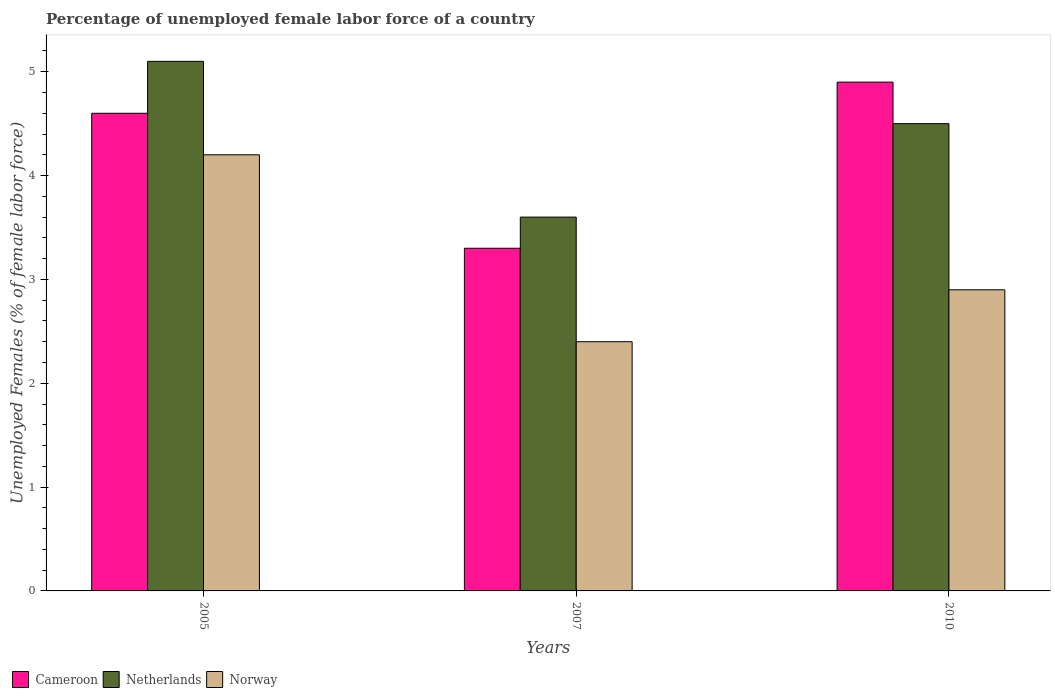How many groups of bars are there?
Provide a short and direct response. 3. Are the number of bars per tick equal to the number of legend labels?
Offer a very short reply. Yes. How many bars are there on the 1st tick from the left?
Provide a short and direct response. 3. How many bars are there on the 1st tick from the right?
Your answer should be compact. 3. What is the label of the 2nd group of bars from the left?
Your answer should be compact. 2007. What is the percentage of unemployed female labor force in Norway in 2010?
Keep it short and to the point. 2.9. Across all years, what is the maximum percentage of unemployed female labor force in Netherlands?
Ensure brevity in your answer.  5.1. Across all years, what is the minimum percentage of unemployed female labor force in Cameroon?
Provide a succinct answer. 3.3. In which year was the percentage of unemployed female labor force in Netherlands minimum?
Your response must be concise. 2007. What is the total percentage of unemployed female labor force in Cameroon in the graph?
Provide a succinct answer. 12.8. What is the difference between the percentage of unemployed female labor force in Norway in 2007 and that in 2010?
Give a very brief answer. -0.5. What is the difference between the percentage of unemployed female labor force in Cameroon in 2010 and the percentage of unemployed female labor force in Netherlands in 2005?
Your response must be concise. -0.2. What is the average percentage of unemployed female labor force in Norway per year?
Offer a terse response. 3.17. In the year 2007, what is the difference between the percentage of unemployed female labor force in Norway and percentage of unemployed female labor force in Netherlands?
Your answer should be very brief. -1.2. What is the ratio of the percentage of unemployed female labor force in Norway in 2005 to that in 2007?
Offer a terse response. 1.75. Is the percentage of unemployed female labor force in Netherlands in 2005 less than that in 2007?
Keep it short and to the point. No. Is the difference between the percentage of unemployed female labor force in Norway in 2005 and 2007 greater than the difference between the percentage of unemployed female labor force in Netherlands in 2005 and 2007?
Offer a terse response. Yes. What is the difference between the highest and the second highest percentage of unemployed female labor force in Norway?
Provide a short and direct response. 1.3. What is the difference between the highest and the lowest percentage of unemployed female labor force in Cameroon?
Offer a terse response. 1.6. In how many years, is the percentage of unemployed female labor force in Netherlands greater than the average percentage of unemployed female labor force in Netherlands taken over all years?
Provide a short and direct response. 2. How many years are there in the graph?
Your answer should be compact. 3. Are the values on the major ticks of Y-axis written in scientific E-notation?
Provide a succinct answer. No. Where does the legend appear in the graph?
Your response must be concise. Bottom left. How many legend labels are there?
Offer a very short reply. 3. How are the legend labels stacked?
Keep it short and to the point. Horizontal. What is the title of the graph?
Provide a succinct answer. Percentage of unemployed female labor force of a country. What is the label or title of the X-axis?
Offer a very short reply. Years. What is the label or title of the Y-axis?
Offer a terse response. Unemployed Females (% of female labor force). What is the Unemployed Females (% of female labor force) in Cameroon in 2005?
Your answer should be very brief. 4.6. What is the Unemployed Females (% of female labor force) in Netherlands in 2005?
Provide a short and direct response. 5.1. What is the Unemployed Females (% of female labor force) in Norway in 2005?
Ensure brevity in your answer.  4.2. What is the Unemployed Females (% of female labor force) in Cameroon in 2007?
Give a very brief answer. 3.3. What is the Unemployed Females (% of female labor force) in Netherlands in 2007?
Offer a terse response. 3.6. What is the Unemployed Females (% of female labor force) of Norway in 2007?
Make the answer very short. 2.4. What is the Unemployed Females (% of female labor force) in Cameroon in 2010?
Provide a succinct answer. 4.9. What is the Unemployed Females (% of female labor force) in Netherlands in 2010?
Your response must be concise. 4.5. What is the Unemployed Females (% of female labor force) in Norway in 2010?
Provide a succinct answer. 2.9. Across all years, what is the maximum Unemployed Females (% of female labor force) of Cameroon?
Provide a short and direct response. 4.9. Across all years, what is the maximum Unemployed Females (% of female labor force) of Netherlands?
Make the answer very short. 5.1. Across all years, what is the maximum Unemployed Females (% of female labor force) of Norway?
Provide a short and direct response. 4.2. Across all years, what is the minimum Unemployed Females (% of female labor force) of Cameroon?
Provide a short and direct response. 3.3. Across all years, what is the minimum Unemployed Females (% of female labor force) in Netherlands?
Provide a succinct answer. 3.6. Across all years, what is the minimum Unemployed Females (% of female labor force) of Norway?
Give a very brief answer. 2.4. What is the total Unemployed Females (% of female labor force) of Cameroon in the graph?
Provide a succinct answer. 12.8. What is the total Unemployed Females (% of female labor force) of Netherlands in the graph?
Your response must be concise. 13.2. What is the total Unemployed Females (% of female labor force) of Norway in the graph?
Provide a succinct answer. 9.5. What is the difference between the Unemployed Females (% of female labor force) in Cameroon in 2005 and that in 2007?
Your answer should be very brief. 1.3. What is the difference between the Unemployed Females (% of female labor force) in Norway in 2005 and that in 2010?
Ensure brevity in your answer.  1.3. What is the difference between the Unemployed Females (% of female labor force) of Cameroon in 2007 and that in 2010?
Give a very brief answer. -1.6. What is the difference between the Unemployed Females (% of female labor force) in Netherlands in 2007 and that in 2010?
Your response must be concise. -0.9. What is the difference between the Unemployed Females (% of female labor force) in Cameroon in 2005 and the Unemployed Females (% of female labor force) in Netherlands in 2007?
Provide a short and direct response. 1. What is the difference between the Unemployed Females (% of female labor force) of Netherlands in 2005 and the Unemployed Females (% of female labor force) of Norway in 2007?
Offer a terse response. 2.7. What is the difference between the Unemployed Females (% of female labor force) in Cameroon in 2007 and the Unemployed Females (% of female labor force) in Norway in 2010?
Offer a very short reply. 0.4. What is the difference between the Unemployed Females (% of female labor force) of Netherlands in 2007 and the Unemployed Females (% of female labor force) of Norway in 2010?
Provide a succinct answer. 0.7. What is the average Unemployed Females (% of female labor force) in Cameroon per year?
Ensure brevity in your answer.  4.27. What is the average Unemployed Females (% of female labor force) of Norway per year?
Make the answer very short. 3.17. In the year 2005, what is the difference between the Unemployed Females (% of female labor force) in Cameroon and Unemployed Females (% of female labor force) in Norway?
Give a very brief answer. 0.4. In the year 2005, what is the difference between the Unemployed Females (% of female labor force) of Netherlands and Unemployed Females (% of female labor force) of Norway?
Your answer should be very brief. 0.9. In the year 2007, what is the difference between the Unemployed Females (% of female labor force) of Cameroon and Unemployed Females (% of female labor force) of Norway?
Your answer should be compact. 0.9. In the year 2007, what is the difference between the Unemployed Females (% of female labor force) in Netherlands and Unemployed Females (% of female labor force) in Norway?
Make the answer very short. 1.2. In the year 2010, what is the difference between the Unemployed Females (% of female labor force) of Cameroon and Unemployed Females (% of female labor force) of Netherlands?
Your answer should be compact. 0.4. In the year 2010, what is the difference between the Unemployed Females (% of female labor force) in Netherlands and Unemployed Females (% of female labor force) in Norway?
Offer a terse response. 1.6. What is the ratio of the Unemployed Females (% of female labor force) of Cameroon in 2005 to that in 2007?
Provide a succinct answer. 1.39. What is the ratio of the Unemployed Females (% of female labor force) of Netherlands in 2005 to that in 2007?
Your answer should be compact. 1.42. What is the ratio of the Unemployed Females (% of female labor force) of Cameroon in 2005 to that in 2010?
Your answer should be compact. 0.94. What is the ratio of the Unemployed Females (% of female labor force) in Netherlands in 2005 to that in 2010?
Keep it short and to the point. 1.13. What is the ratio of the Unemployed Females (% of female labor force) in Norway in 2005 to that in 2010?
Ensure brevity in your answer.  1.45. What is the ratio of the Unemployed Females (% of female labor force) in Cameroon in 2007 to that in 2010?
Your answer should be very brief. 0.67. What is the ratio of the Unemployed Females (% of female labor force) in Norway in 2007 to that in 2010?
Your answer should be very brief. 0.83. What is the difference between the highest and the second highest Unemployed Females (% of female labor force) of Cameroon?
Ensure brevity in your answer.  0.3. What is the difference between the highest and the lowest Unemployed Females (% of female labor force) in Cameroon?
Offer a terse response. 1.6. What is the difference between the highest and the lowest Unemployed Females (% of female labor force) of Netherlands?
Provide a short and direct response. 1.5. 